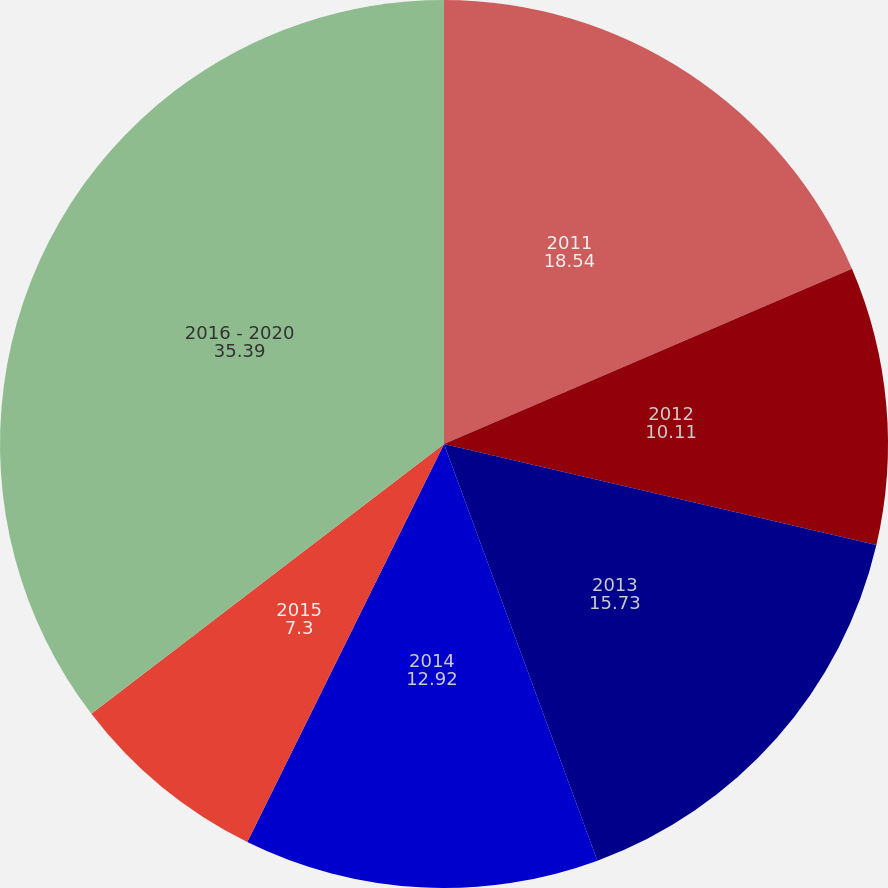Convert chart to OTSL. <chart><loc_0><loc_0><loc_500><loc_500><pie_chart><fcel>2011<fcel>2012<fcel>2013<fcel>2014<fcel>2015<fcel>2016 - 2020<nl><fcel>18.54%<fcel>10.11%<fcel>15.73%<fcel>12.92%<fcel>7.3%<fcel>35.39%<nl></chart> 